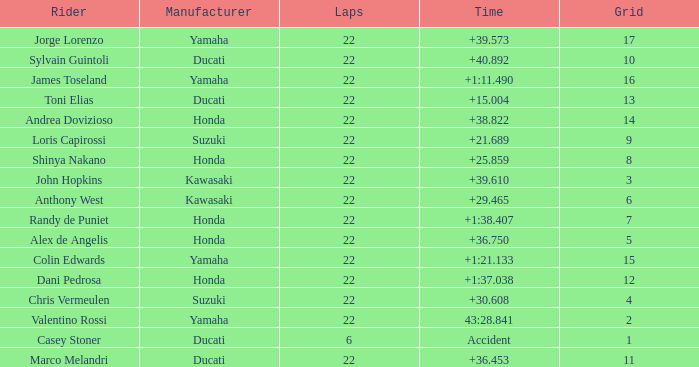What grid is Ducati with fewer than 22 laps? 1.0. 